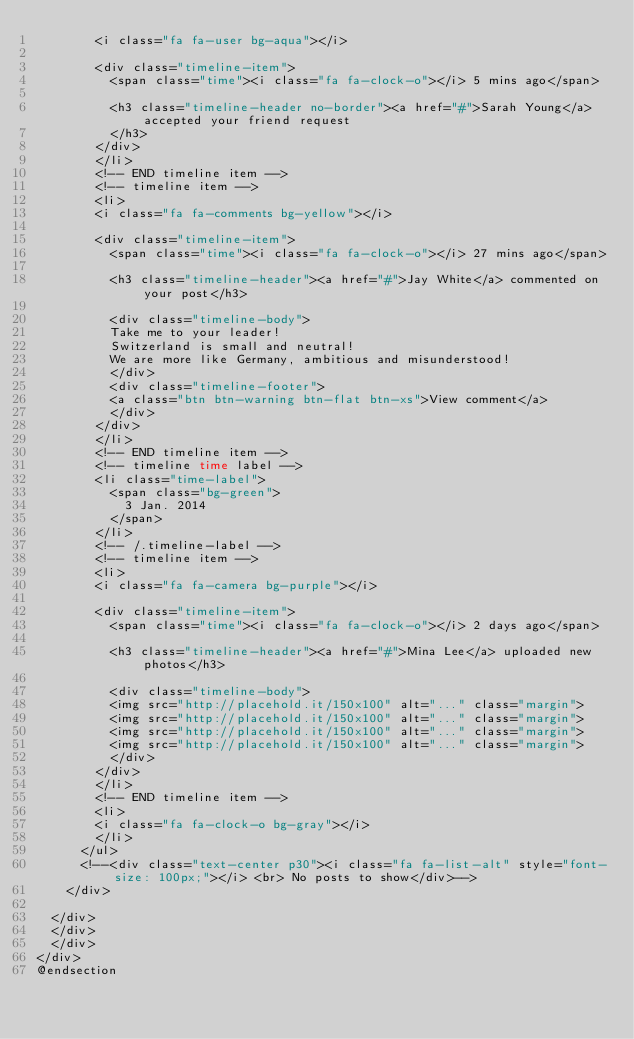Convert code to text. <code><loc_0><loc_0><loc_500><loc_500><_PHP_>				<i class="fa fa-user bg-aqua"></i>

				<div class="timeline-item">
					<span class="time"><i class="fa fa-clock-o"></i> 5 mins ago</span>

					<h3 class="timeline-header no-border"><a href="#">Sarah Young</a> accepted your friend request
					</h3>
				</div>
				</li>
				<!-- END timeline item -->
				<!-- timeline item -->
				<li>
				<i class="fa fa-comments bg-yellow"></i>

				<div class="timeline-item">
					<span class="time"><i class="fa fa-clock-o"></i> 27 mins ago</span>

					<h3 class="timeline-header"><a href="#">Jay White</a> commented on your post</h3>

					<div class="timeline-body">
					Take me to your leader!
					Switzerland is small and neutral!
					We are more like Germany, ambitious and misunderstood!
					</div>
					<div class="timeline-footer">
					<a class="btn btn-warning btn-flat btn-xs">View comment</a>
					</div>
				</div>
				</li>
				<!-- END timeline item -->
				<!-- timeline time label -->
				<li class="time-label">
					<span class="bg-green">
						3 Jan. 2014
					</span>
				</li>
				<!-- /.timeline-label -->
				<!-- timeline item -->
				<li>
				<i class="fa fa-camera bg-purple"></i>

				<div class="timeline-item">
					<span class="time"><i class="fa fa-clock-o"></i> 2 days ago</span>

					<h3 class="timeline-header"><a href="#">Mina Lee</a> uploaded new photos</h3>

					<div class="timeline-body">
					<img src="http://placehold.it/150x100" alt="..." class="margin">
					<img src="http://placehold.it/150x100" alt="..." class="margin">
					<img src="http://placehold.it/150x100" alt="..." class="margin">
					<img src="http://placehold.it/150x100" alt="..." class="margin">
					</div>
				</div>
				</li>
				<!-- END timeline item -->
				<li>
				<i class="fa fa-clock-o bg-gray"></i>
				</li>
			</ul>
			<!--<div class="text-center p30"><i class="fa fa-list-alt" style="font-size: 100px;"></i> <br> No posts to show</div>-->
		</div>
		
	</div>
	</div>
	</div>
</div>
@endsection
</code> 